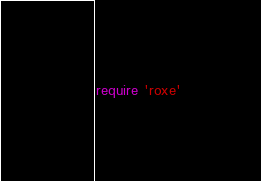Convert code to text. <code><loc_0><loc_0><loc_500><loc_500><_Ruby_>require 'roxe'
</code> 